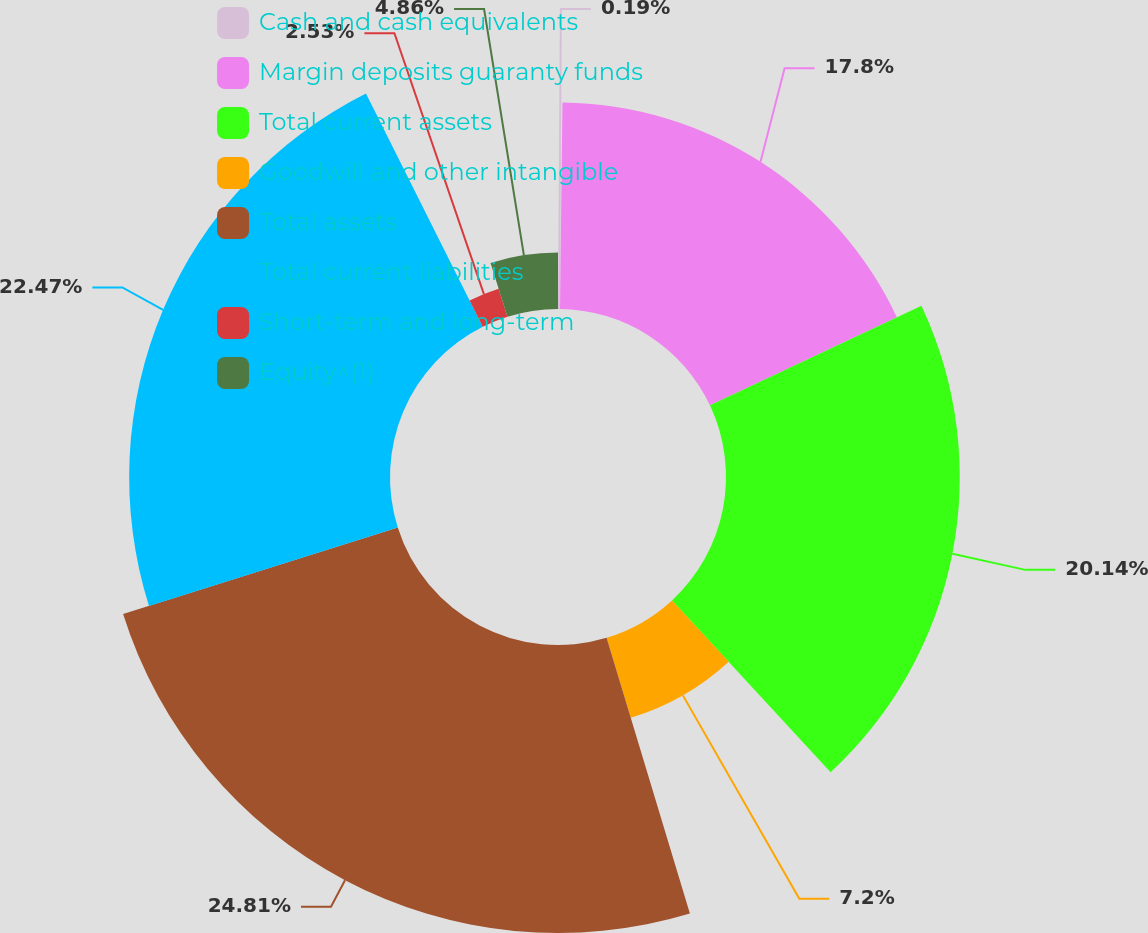Convert chart. <chart><loc_0><loc_0><loc_500><loc_500><pie_chart><fcel>Cash and cash equivalents<fcel>Margin deposits guaranty funds<fcel>Total current assets<fcel>Goodwill and other intangible<fcel>Total assets<fcel>Total current liabilities<fcel>Short-term and long-term<fcel>Equity^(1)<nl><fcel>0.19%<fcel>17.8%<fcel>20.14%<fcel>7.2%<fcel>24.81%<fcel>22.47%<fcel>2.53%<fcel>4.86%<nl></chart> 